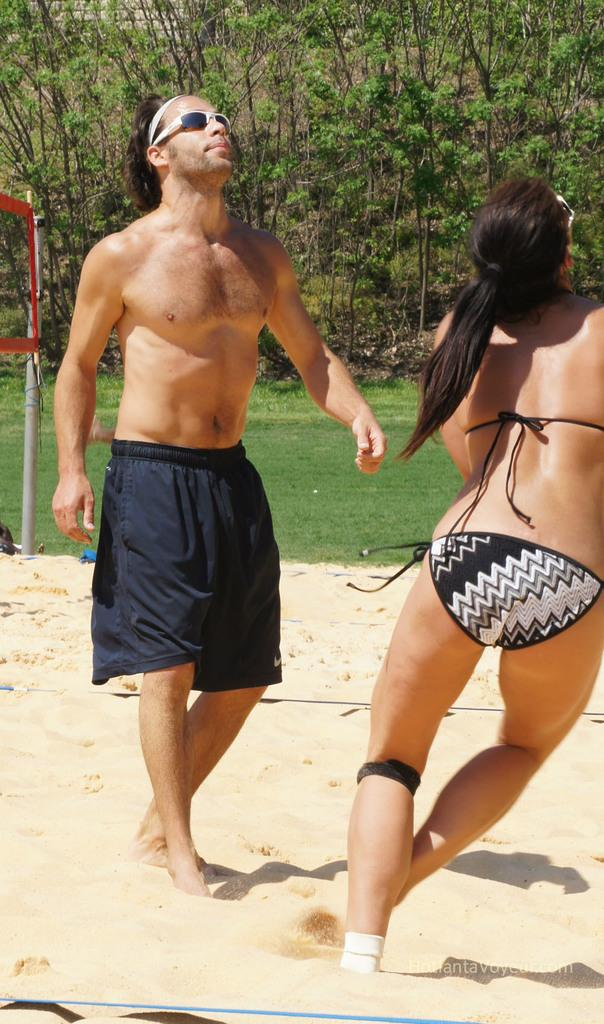How many people are present in the image? There is a man and a woman in the image. What type of surface can be seen in the image? There is sand in the image. What sports equipment is visible in the image? There is a sports net with a pole in the image. What can be seen in the background of the image? There are trees in the background of the image. Is there any additional marking or feature on the image? Yes, there is a watermark on the image. What type of box is being used as a canvas in the image? There is no box or canvas present in the image. How does the image start, and what is the first scene? The image is a still photograph and does not have a starting point or scenes. 